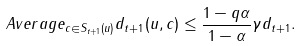Convert formula to latex. <formula><loc_0><loc_0><loc_500><loc_500>A v e r a g e _ { c \in S _ { t + 1 } ( u ) } d _ { t + 1 } ( u , c ) \leq \frac { 1 - q \alpha } { 1 - \alpha } \gamma d _ { t + 1 } .</formula> 